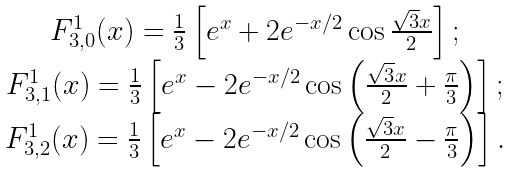Convert formula to latex. <formula><loc_0><loc_0><loc_500><loc_500>\begin{array} { c } F _ { 3 , 0 } ^ { 1 } ( x ) = \frac { 1 } { 3 } \left [ e ^ { x } + 2 e ^ { - x / 2 } \cos \frac { \sqrt { 3 } x } { 2 } \right ] ; \\ F _ { 3 , 1 } ^ { 1 } ( x ) = \frac { 1 } { 3 } \left [ e ^ { x } - 2 e ^ { - x / 2 } \cos \left ( \frac { \sqrt { 3 } x } { 2 } + \frac { \pi } { 3 } \right ) \right ] ; \\ F _ { 3 , 2 } ^ { 1 } ( x ) = \frac { 1 } { 3 } \left [ e ^ { x } - 2 e ^ { - x / 2 } \cos \left ( \frac { \sqrt { 3 } x } { 2 } - \frac { \pi } { 3 } \right ) \right ] . \end{array}</formula> 